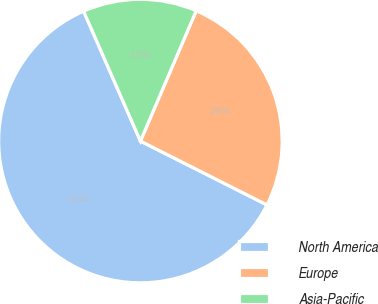<chart> <loc_0><loc_0><loc_500><loc_500><pie_chart><fcel>North America<fcel>Europe<fcel>Asia-Pacific<nl><fcel>61.0%<fcel>26.0%<fcel>13.0%<nl></chart> 